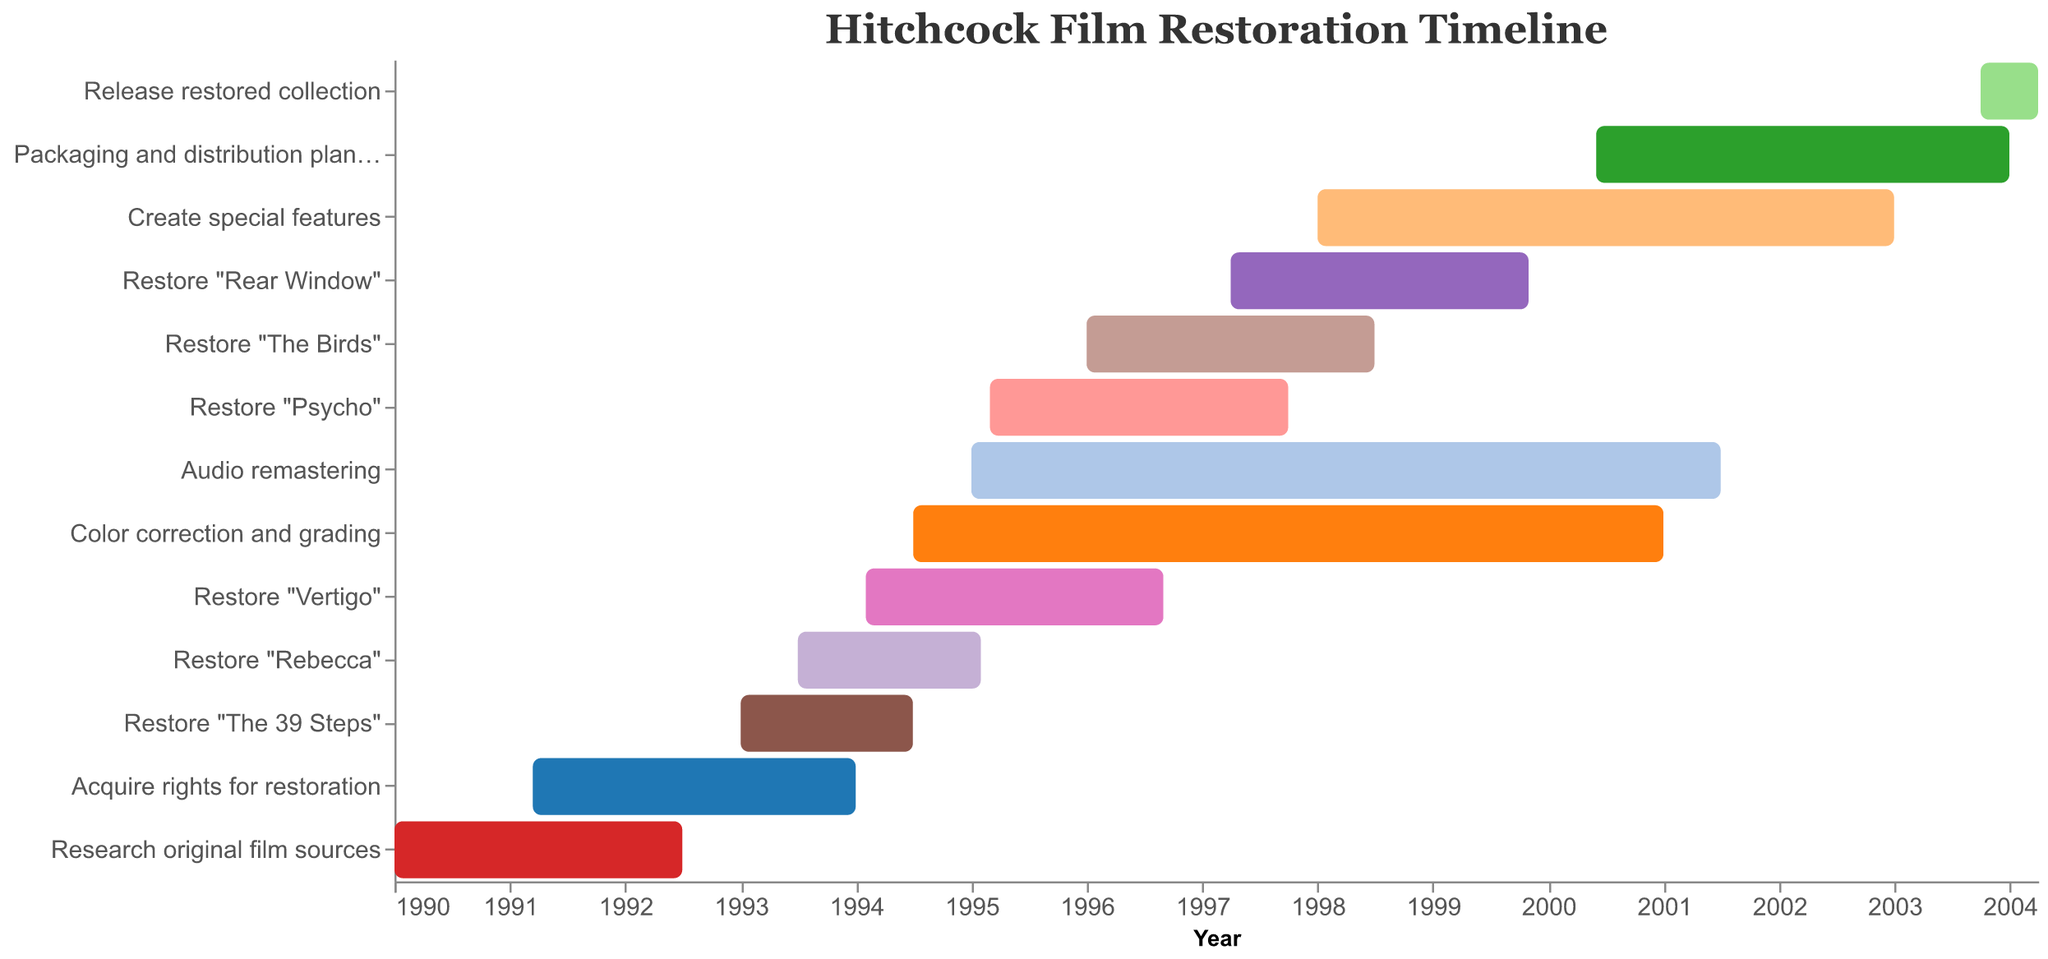What is the title of the Gantt chart? The title is usually shown at the top of the chart, indicating its overall subject or focus. In this chart, the title clearly describes its content.
Answer: Hitchcock Film Restoration Timeline Which task has the earliest start date? By looking at the leftmost bar which represents the earliest starting point on the x-axis, we can determine the earliest task.
Answer: Research original film sources What is the duration of the task "Restore Psycho"? The duration is measured by finding the difference between the start and end dates of the task.
Answer: 2 years and 7 months Which tasks were carried out simultaneously in 1995? To find overlapping tasks in 1995, look for tasks that have bars spanning the year 1995 on the x-axis.
Answer: Restore "Rebecca", Restore "Vertigo", Color correction and grading, Audio remastering What is the average duration of the film restoration tasks? Calculate the duration for each restoration task (in months or years), sum them up, and then divide by the number of tasks to find the average.
Answer: Approximately 2 years During which period were the most tasks being performed concurrently? Identify the time span where the maximum number of bars overlap on the x-axis. Count the overlapping tasks for each period to find the maximum.
Answer: Late 1995 to early 1996 Which task took the longest to complete? Compare the bars' lengths on the Gantt chart to find the task with the longest duration.
Answer: Audio remastering (1995-2001) How long did it take to release the restored collection after starting the packaging and distribution planning? Calculate the time difference from the start of "Packaging and distribution planning" to the end of "Release restored collection".
Answer: Approximately 3 years and 7 months How did the time taken for "Restore Psycho" compare to "Restore The Birds"? Compare the duration of "Restore Psycho" (2 years and 7 months) to "Restore The Birds" (2 years and 6 months).
Answer: Slightly longer by 1 month 